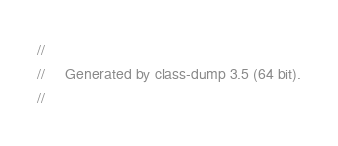<code> <loc_0><loc_0><loc_500><loc_500><_C_>//
//     Generated by class-dump 3.5 (64 bit).
//</code> 